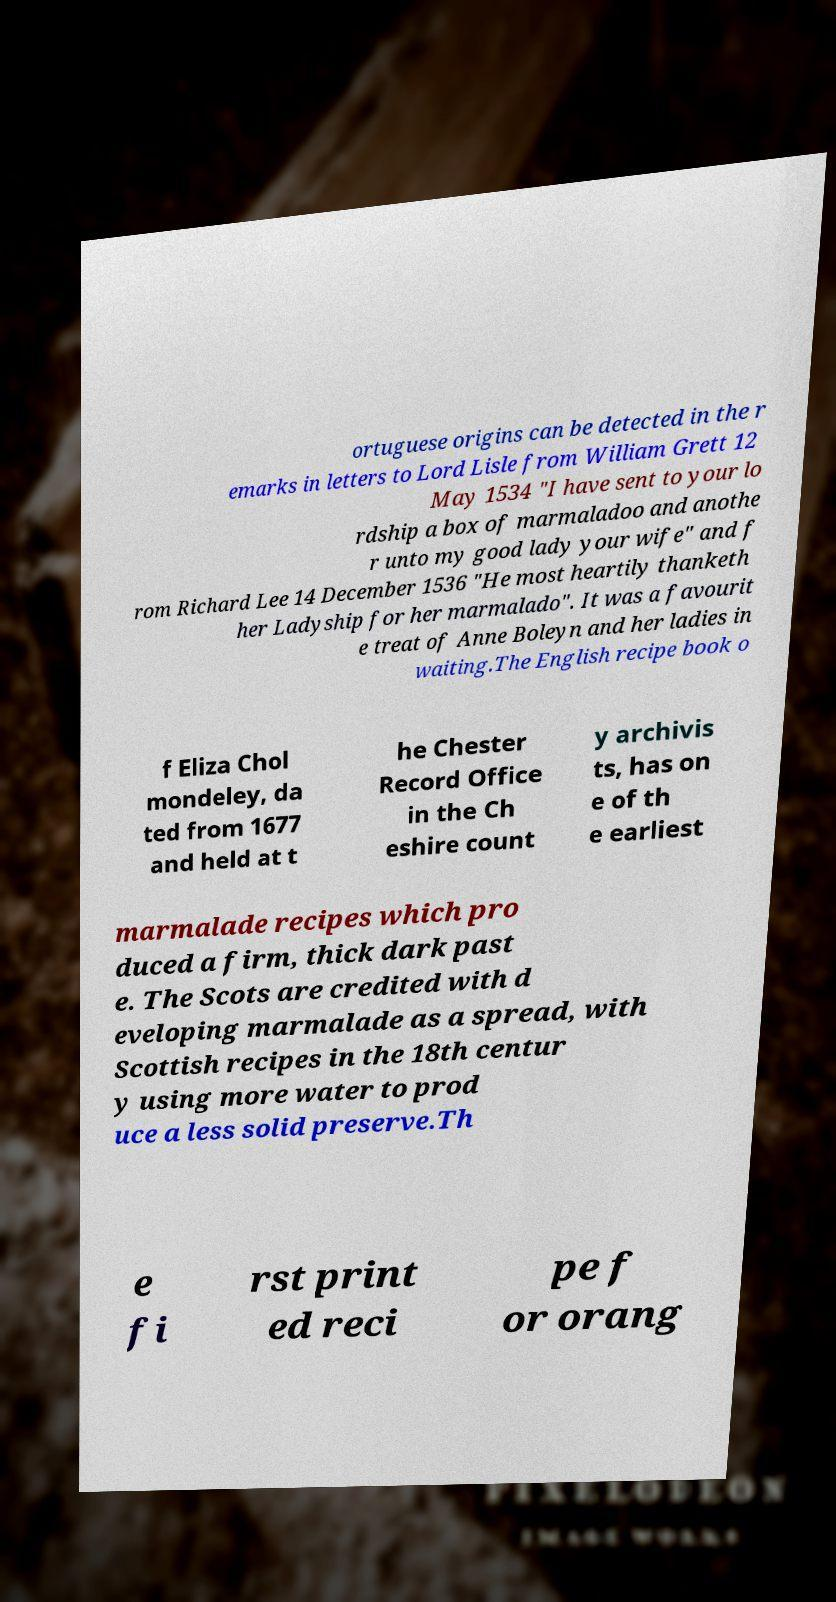For documentation purposes, I need the text within this image transcribed. Could you provide that? ortuguese origins can be detected in the r emarks in letters to Lord Lisle from William Grett 12 May 1534 "I have sent to your lo rdship a box of marmaladoo and anothe r unto my good lady your wife" and f rom Richard Lee 14 December 1536 "He most heartily thanketh her Ladyship for her marmalado". It was a favourit e treat of Anne Boleyn and her ladies in waiting.The English recipe book o f Eliza Chol mondeley, da ted from 1677 and held at t he Chester Record Office in the Ch eshire count y archivis ts, has on e of th e earliest marmalade recipes which pro duced a firm, thick dark past e. The Scots are credited with d eveloping marmalade as a spread, with Scottish recipes in the 18th centur y using more water to prod uce a less solid preserve.Th e fi rst print ed reci pe f or orang 